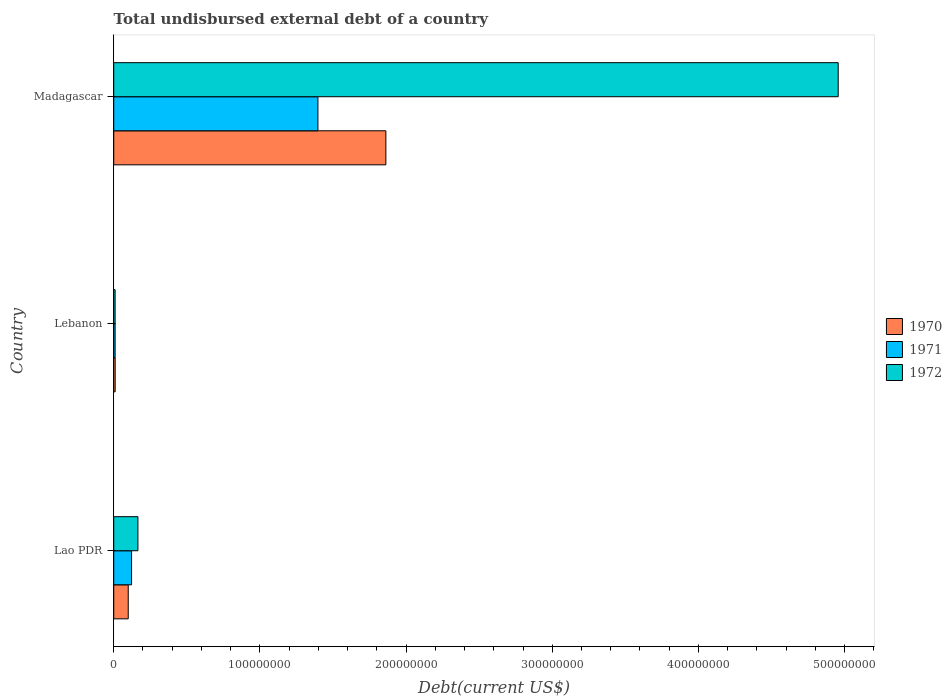How many different coloured bars are there?
Your answer should be very brief. 3. Are the number of bars per tick equal to the number of legend labels?
Provide a short and direct response. Yes. How many bars are there on the 3rd tick from the top?
Ensure brevity in your answer.  3. What is the label of the 2nd group of bars from the top?
Offer a very short reply. Lebanon. In how many cases, is the number of bars for a given country not equal to the number of legend labels?
Make the answer very short. 0. What is the total undisbursed external debt in 1970 in Lebanon?
Provide a short and direct response. 9.80e+05. Across all countries, what is the maximum total undisbursed external debt in 1972?
Provide a short and direct response. 4.96e+08. Across all countries, what is the minimum total undisbursed external debt in 1971?
Your answer should be compact. 9.32e+05. In which country was the total undisbursed external debt in 1972 maximum?
Offer a terse response. Madagascar. In which country was the total undisbursed external debt in 1972 minimum?
Offer a very short reply. Lebanon. What is the total total undisbursed external debt in 1970 in the graph?
Provide a short and direct response. 1.97e+08. What is the difference between the total undisbursed external debt in 1972 in Lebanon and that in Madagascar?
Offer a very short reply. -4.95e+08. What is the difference between the total undisbursed external debt in 1970 in Lebanon and the total undisbursed external debt in 1971 in Madagascar?
Offer a very short reply. -1.39e+08. What is the average total undisbursed external debt in 1971 per country?
Make the answer very short. 5.09e+07. What is the difference between the total undisbursed external debt in 1970 and total undisbursed external debt in 1971 in Lao PDR?
Offer a very short reply. -2.28e+06. What is the ratio of the total undisbursed external debt in 1971 in Lao PDR to that in Madagascar?
Make the answer very short. 0.09. What is the difference between the highest and the second highest total undisbursed external debt in 1972?
Make the answer very short. 4.79e+08. What is the difference between the highest and the lowest total undisbursed external debt in 1970?
Make the answer very short. 1.85e+08. What does the 3rd bar from the bottom in Madagascar represents?
Offer a very short reply. 1972. How many bars are there?
Your answer should be compact. 9. What is the difference between two consecutive major ticks on the X-axis?
Ensure brevity in your answer.  1.00e+08. How many legend labels are there?
Keep it short and to the point. 3. What is the title of the graph?
Provide a short and direct response. Total undisbursed external debt of a country. What is the label or title of the X-axis?
Your answer should be compact. Debt(current US$). What is the Debt(current US$) of 1970 in Lao PDR?
Offer a terse response. 9.92e+06. What is the Debt(current US$) of 1971 in Lao PDR?
Your answer should be compact. 1.22e+07. What is the Debt(current US$) of 1972 in Lao PDR?
Provide a short and direct response. 1.65e+07. What is the Debt(current US$) of 1970 in Lebanon?
Offer a terse response. 9.80e+05. What is the Debt(current US$) in 1971 in Lebanon?
Offer a very short reply. 9.32e+05. What is the Debt(current US$) of 1972 in Lebanon?
Provide a succinct answer. 9.32e+05. What is the Debt(current US$) of 1970 in Madagascar?
Provide a succinct answer. 1.86e+08. What is the Debt(current US$) of 1971 in Madagascar?
Give a very brief answer. 1.40e+08. What is the Debt(current US$) of 1972 in Madagascar?
Offer a very short reply. 4.96e+08. Across all countries, what is the maximum Debt(current US$) in 1970?
Give a very brief answer. 1.86e+08. Across all countries, what is the maximum Debt(current US$) in 1971?
Offer a terse response. 1.40e+08. Across all countries, what is the maximum Debt(current US$) of 1972?
Provide a succinct answer. 4.96e+08. Across all countries, what is the minimum Debt(current US$) of 1970?
Offer a terse response. 9.80e+05. Across all countries, what is the minimum Debt(current US$) in 1971?
Offer a terse response. 9.32e+05. Across all countries, what is the minimum Debt(current US$) in 1972?
Your answer should be compact. 9.32e+05. What is the total Debt(current US$) in 1970 in the graph?
Ensure brevity in your answer.  1.97e+08. What is the total Debt(current US$) in 1971 in the graph?
Make the answer very short. 1.53e+08. What is the total Debt(current US$) in 1972 in the graph?
Your answer should be compact. 5.13e+08. What is the difference between the Debt(current US$) in 1970 in Lao PDR and that in Lebanon?
Provide a short and direct response. 8.94e+06. What is the difference between the Debt(current US$) in 1971 in Lao PDR and that in Lebanon?
Ensure brevity in your answer.  1.13e+07. What is the difference between the Debt(current US$) in 1972 in Lao PDR and that in Lebanon?
Your answer should be very brief. 1.56e+07. What is the difference between the Debt(current US$) in 1970 in Lao PDR and that in Madagascar?
Your response must be concise. -1.76e+08. What is the difference between the Debt(current US$) of 1971 in Lao PDR and that in Madagascar?
Your response must be concise. -1.27e+08. What is the difference between the Debt(current US$) of 1972 in Lao PDR and that in Madagascar?
Offer a terse response. -4.79e+08. What is the difference between the Debt(current US$) of 1970 in Lebanon and that in Madagascar?
Offer a very short reply. -1.85e+08. What is the difference between the Debt(current US$) in 1971 in Lebanon and that in Madagascar?
Offer a terse response. -1.39e+08. What is the difference between the Debt(current US$) in 1972 in Lebanon and that in Madagascar?
Provide a succinct answer. -4.95e+08. What is the difference between the Debt(current US$) of 1970 in Lao PDR and the Debt(current US$) of 1971 in Lebanon?
Offer a very short reply. 8.98e+06. What is the difference between the Debt(current US$) of 1970 in Lao PDR and the Debt(current US$) of 1972 in Lebanon?
Your response must be concise. 8.98e+06. What is the difference between the Debt(current US$) of 1971 in Lao PDR and the Debt(current US$) of 1972 in Lebanon?
Give a very brief answer. 1.13e+07. What is the difference between the Debt(current US$) of 1970 in Lao PDR and the Debt(current US$) of 1971 in Madagascar?
Provide a short and direct response. -1.30e+08. What is the difference between the Debt(current US$) in 1970 in Lao PDR and the Debt(current US$) in 1972 in Madagascar?
Make the answer very short. -4.86e+08. What is the difference between the Debt(current US$) of 1971 in Lao PDR and the Debt(current US$) of 1972 in Madagascar?
Provide a succinct answer. -4.83e+08. What is the difference between the Debt(current US$) in 1970 in Lebanon and the Debt(current US$) in 1971 in Madagascar?
Offer a terse response. -1.39e+08. What is the difference between the Debt(current US$) of 1970 in Lebanon and the Debt(current US$) of 1972 in Madagascar?
Your response must be concise. -4.95e+08. What is the difference between the Debt(current US$) of 1971 in Lebanon and the Debt(current US$) of 1972 in Madagascar?
Offer a terse response. -4.95e+08. What is the average Debt(current US$) of 1970 per country?
Provide a short and direct response. 6.57e+07. What is the average Debt(current US$) in 1971 per country?
Provide a short and direct response. 5.09e+07. What is the average Debt(current US$) of 1972 per country?
Give a very brief answer. 1.71e+08. What is the difference between the Debt(current US$) of 1970 and Debt(current US$) of 1971 in Lao PDR?
Provide a succinct answer. -2.28e+06. What is the difference between the Debt(current US$) of 1970 and Debt(current US$) of 1972 in Lao PDR?
Offer a terse response. -6.63e+06. What is the difference between the Debt(current US$) in 1971 and Debt(current US$) in 1972 in Lao PDR?
Keep it short and to the point. -4.35e+06. What is the difference between the Debt(current US$) of 1970 and Debt(current US$) of 1971 in Lebanon?
Your response must be concise. 4.80e+04. What is the difference between the Debt(current US$) of 1970 and Debt(current US$) of 1972 in Lebanon?
Offer a terse response. 4.80e+04. What is the difference between the Debt(current US$) in 1971 and Debt(current US$) in 1972 in Lebanon?
Your response must be concise. 0. What is the difference between the Debt(current US$) in 1970 and Debt(current US$) in 1971 in Madagascar?
Your response must be concise. 4.65e+07. What is the difference between the Debt(current US$) in 1970 and Debt(current US$) in 1972 in Madagascar?
Offer a terse response. -3.09e+08. What is the difference between the Debt(current US$) of 1971 and Debt(current US$) of 1972 in Madagascar?
Keep it short and to the point. -3.56e+08. What is the ratio of the Debt(current US$) of 1970 in Lao PDR to that in Lebanon?
Your response must be concise. 10.12. What is the ratio of the Debt(current US$) of 1971 in Lao PDR to that in Lebanon?
Provide a short and direct response. 13.09. What is the ratio of the Debt(current US$) of 1972 in Lao PDR to that in Lebanon?
Ensure brevity in your answer.  17.75. What is the ratio of the Debt(current US$) in 1970 in Lao PDR to that in Madagascar?
Ensure brevity in your answer.  0.05. What is the ratio of the Debt(current US$) of 1971 in Lao PDR to that in Madagascar?
Give a very brief answer. 0.09. What is the ratio of the Debt(current US$) in 1972 in Lao PDR to that in Madagascar?
Ensure brevity in your answer.  0.03. What is the ratio of the Debt(current US$) in 1970 in Lebanon to that in Madagascar?
Offer a very short reply. 0.01. What is the ratio of the Debt(current US$) of 1971 in Lebanon to that in Madagascar?
Your answer should be very brief. 0.01. What is the ratio of the Debt(current US$) in 1972 in Lebanon to that in Madagascar?
Provide a succinct answer. 0. What is the difference between the highest and the second highest Debt(current US$) in 1970?
Make the answer very short. 1.76e+08. What is the difference between the highest and the second highest Debt(current US$) of 1971?
Your answer should be very brief. 1.27e+08. What is the difference between the highest and the second highest Debt(current US$) in 1972?
Make the answer very short. 4.79e+08. What is the difference between the highest and the lowest Debt(current US$) of 1970?
Offer a very short reply. 1.85e+08. What is the difference between the highest and the lowest Debt(current US$) in 1971?
Your answer should be very brief. 1.39e+08. What is the difference between the highest and the lowest Debt(current US$) of 1972?
Your response must be concise. 4.95e+08. 